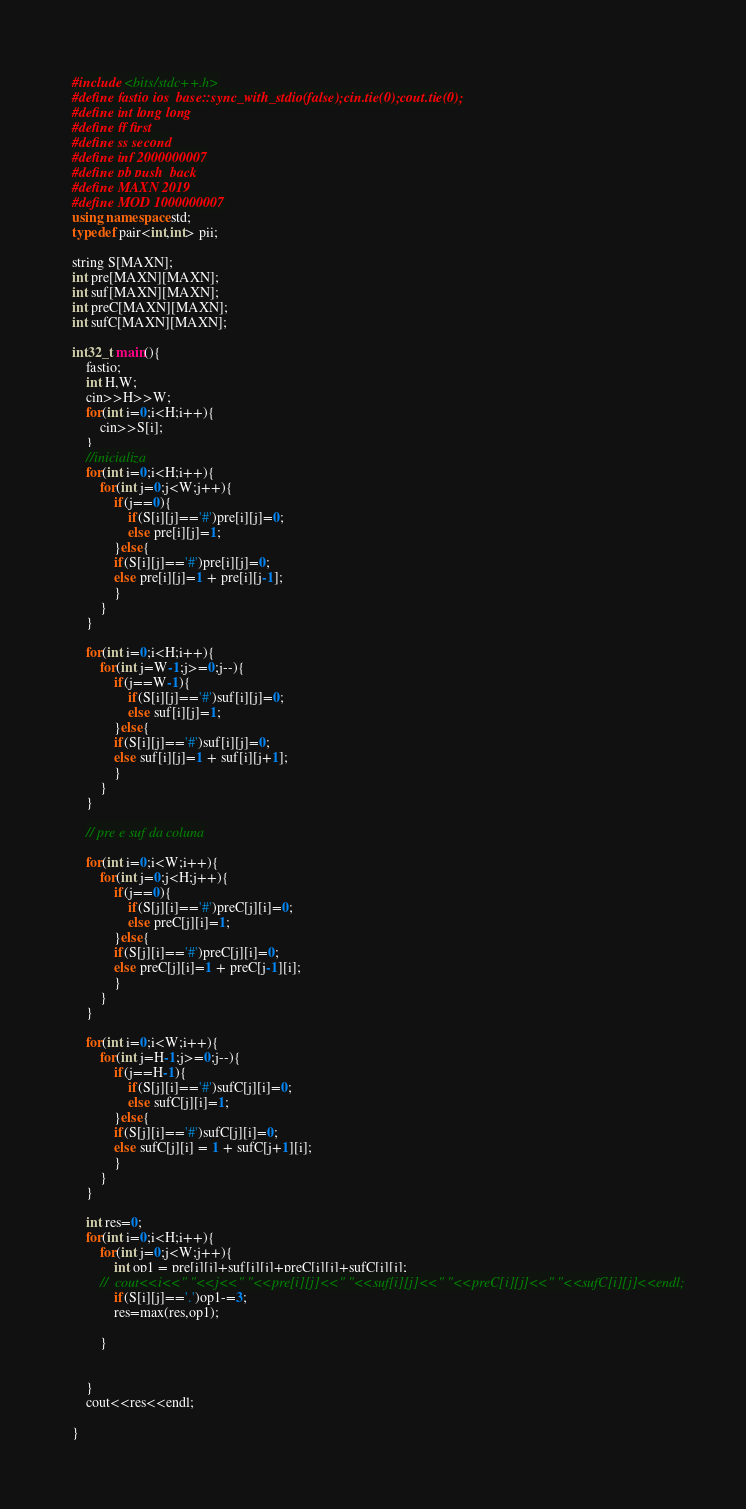<code> <loc_0><loc_0><loc_500><loc_500><_C++_>#include <bits/stdc++.h>
#define fastio ios_base::sync_with_stdio(false);cin.tie(0);cout.tie(0);
#define int long long
#define ff first
#define ss second
#define inf 2000000007
#define pb push_back
#define MAXN 2019
#define MOD 1000000007
using namespace std;
typedef pair<int,int> pii;

string S[MAXN];
int pre[MAXN][MAXN];
int suf[MAXN][MAXN];
int preC[MAXN][MAXN];
int sufC[MAXN][MAXN];

int32_t main(){
	fastio;
	int H,W;
	cin>>H>>W;
	for(int i=0;i<H;i++){
		cin>>S[i];
	}
	//inicializa 
	for(int i=0;i<H;i++){
		for(int j=0;j<W;j++){
			if(j==0){
				if(S[i][j]=='#')pre[i][j]=0;
				else pre[i][j]=1;
			}else{
			if(S[i][j]=='#')pre[i][j]=0;
			else pre[i][j]=1 + pre[i][j-1];
			}
		}
	}
	
	for(int i=0;i<H;i++){
		for(int j=W-1;j>=0;j--){
			if(j==W-1){
				if(S[i][j]=='#')suf[i][j]=0;
				else suf[i][j]=1;
			}else{
			if(S[i][j]=='#')suf[i][j]=0;
			else suf[i][j]=1 + suf[i][j+1];
			}
		}
	}

	// pre e suf da coluna
	
	for(int i=0;i<W;i++){
		for(int j=0;j<H;j++){
			if(j==0){
				if(S[j][i]=='#')preC[j][i]=0;
				else preC[j][i]=1;
			}else{
			if(S[j][i]=='#')preC[j][i]=0;
			else preC[j][i]=1 + preC[j-1][i];
			}
		}
	}
	
	for(int i=0;i<W;i++){
		for(int j=H-1;j>=0;j--){
			if(j==H-1){
				if(S[j][i]=='#')sufC[j][i]=0;
				else sufC[j][i]=1;
			}else{
			if(S[j][i]=='#')sufC[j][i]=0;
			else sufC[j][i] = 1 + sufC[j+1][i];
			}
		}
	}
	
	int res=0;
	for(int i=0;i<H;i++){
		for(int j=0;j<W;j++){
			int op1 = pre[i][j]+suf[i][j]+preC[i][j]+sufC[i][j];
		//	cout<<i<<" "<<j<<" "<<pre[i][j]<<" "<<suf[i][j]<<" "<<preC[i][j]<<" "<<sufC[i][j]<<endl;
			if(S[i][j]=='.')op1-=3;
			res=max(res,op1);
			
		}
		
		
	}
	cout<<res<<endl;
	
}</code> 